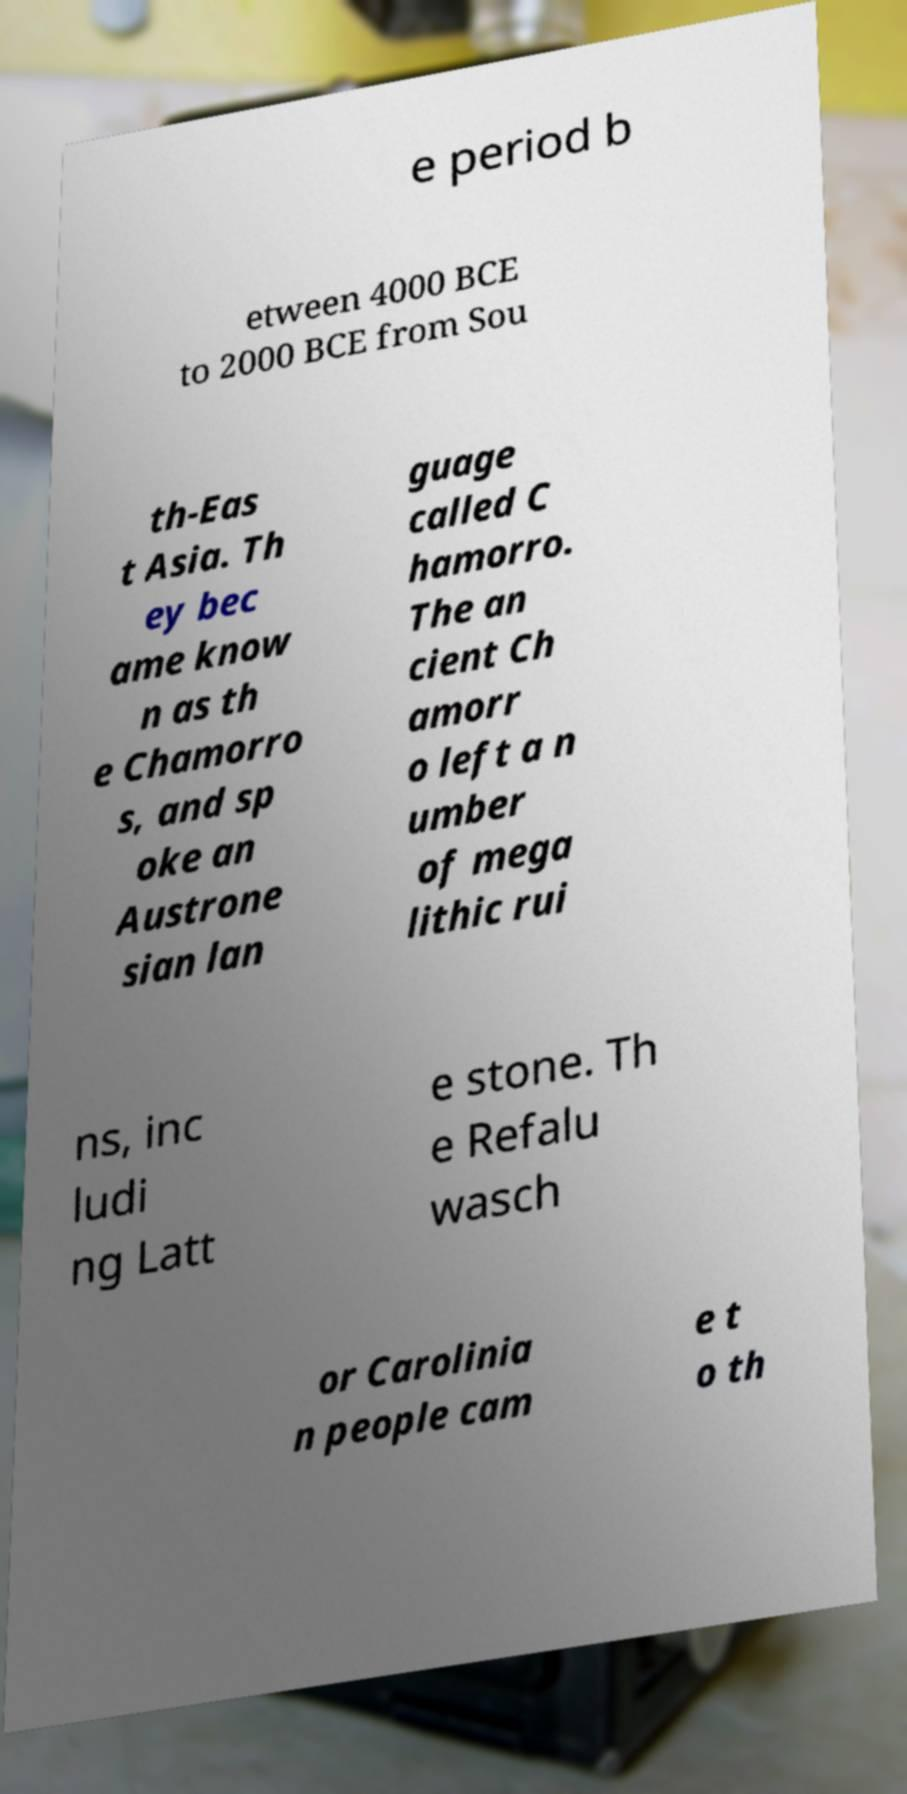Please read and relay the text visible in this image. What does it say? e period b etween 4000 BCE to 2000 BCE from Sou th-Eas t Asia. Th ey bec ame know n as th e Chamorro s, and sp oke an Austrone sian lan guage called C hamorro. The an cient Ch amorr o left a n umber of mega lithic rui ns, inc ludi ng Latt e stone. Th e Refalu wasch or Carolinia n people cam e t o th 